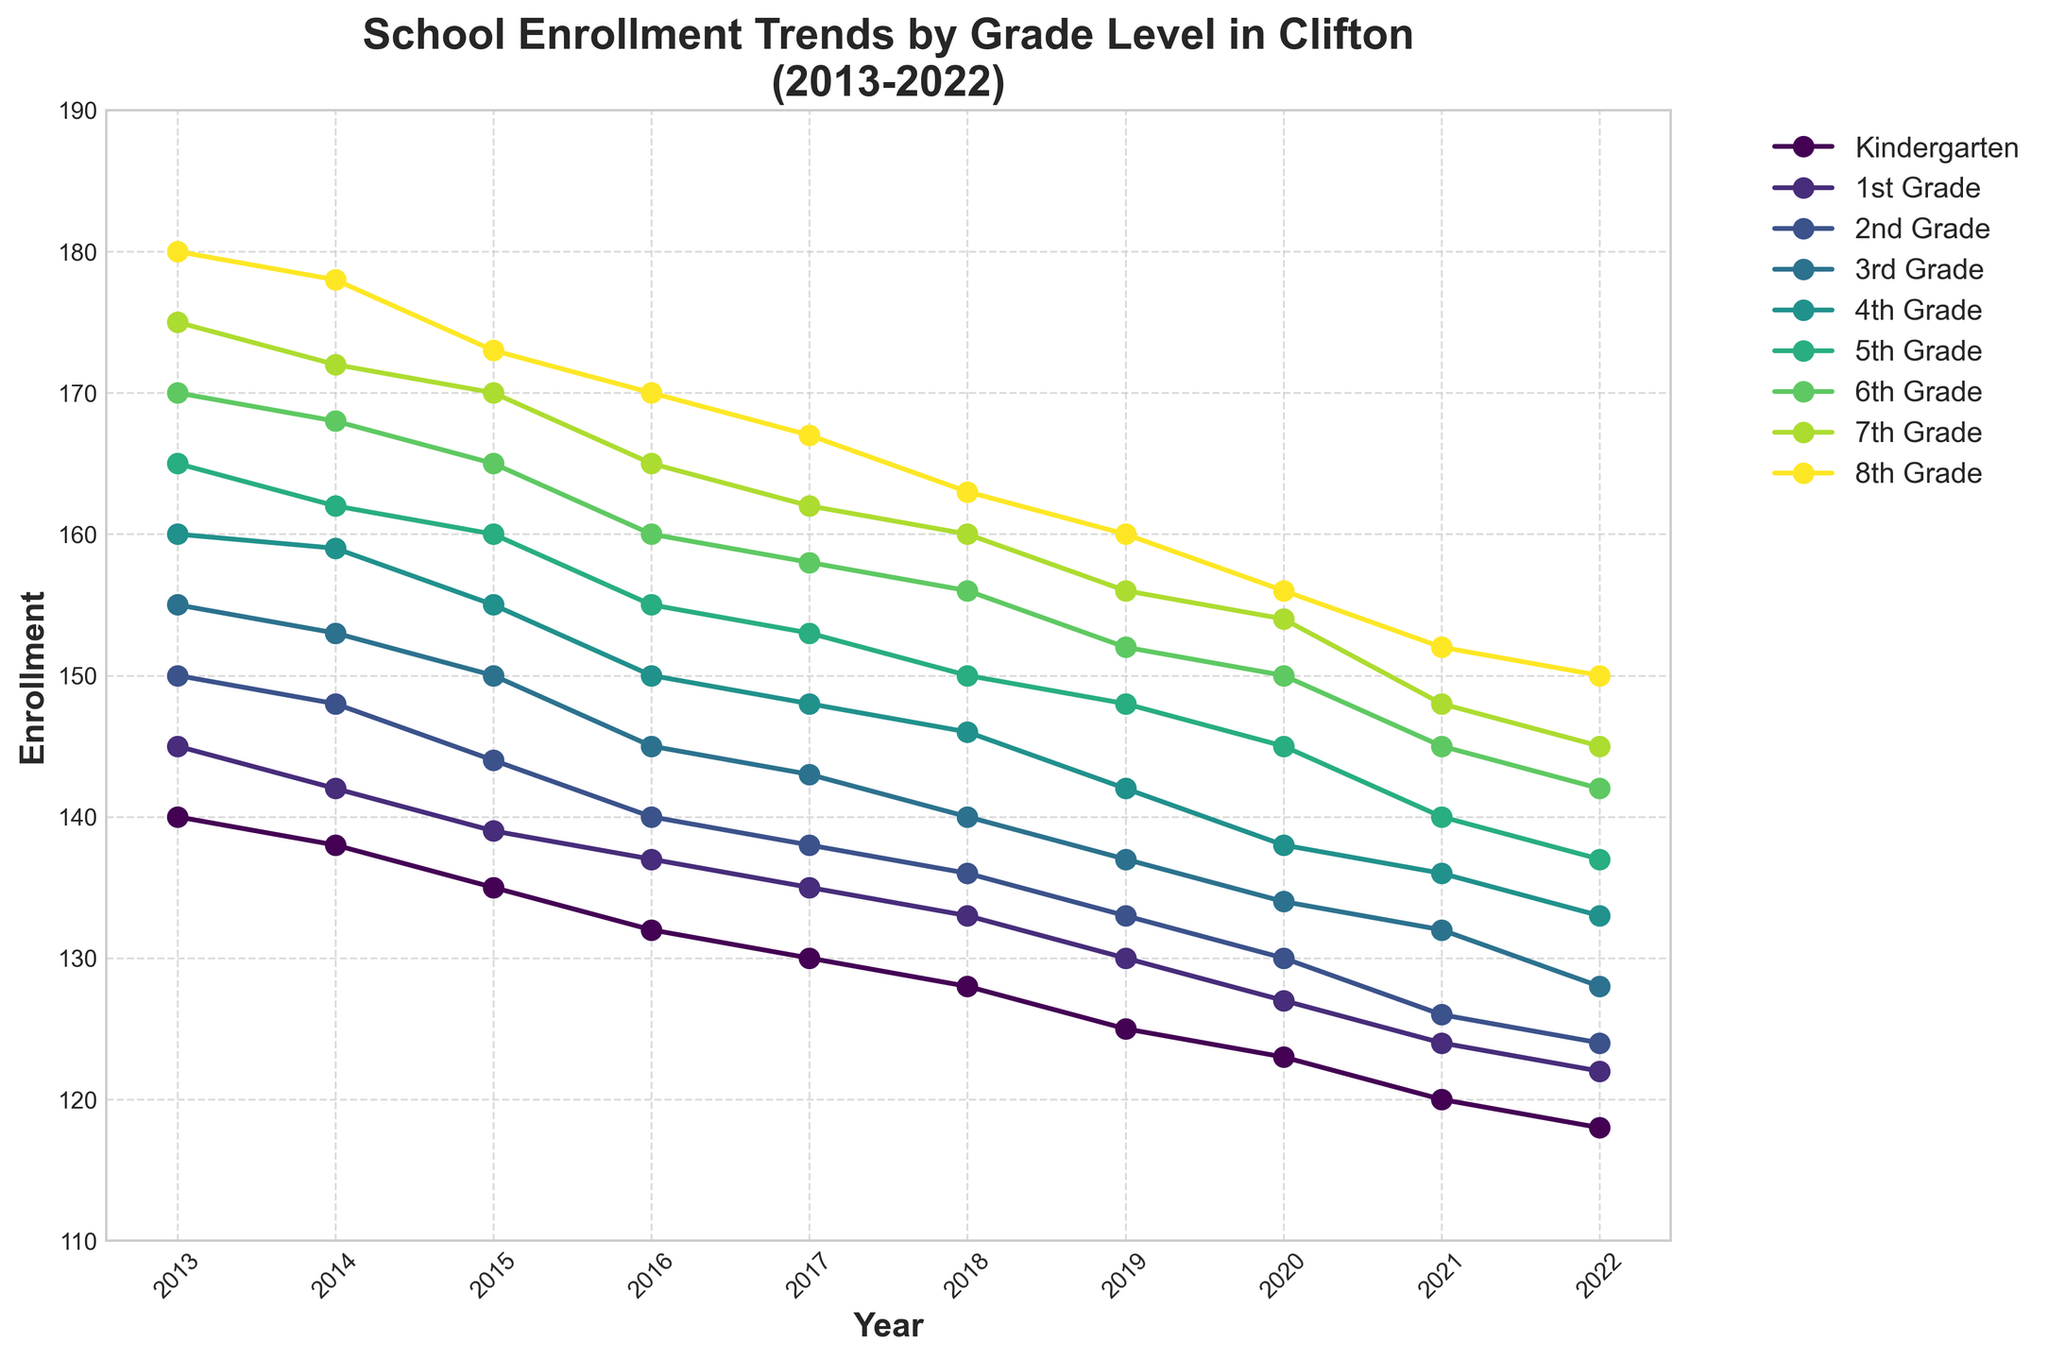What is the range of years shown in the plot? The x-axis displays the years that are covered in this time series plot. By looking at the leftmost and rightmost tick labels on the x-axis, we can determine the range of years.
Answer: 2013 to 2022 What trend can be observed for Kindergarten enrollment from 2013 to 2022? By observing the trend line for Kindergarten in the plot, we can see if it is increasing, decreasing, or stable over the years. The number of enrolled students is consistently decreasing year by year.
Answer: Decreasing Which grade had the highest enrollment in 2022? To determine the grade with the highest enrollment in 2022, observe the endpoints of each grade's line in the plot and identify the one that is at the highest position on the y-axis for the year 2022.
Answer: 8th Grade How does the enrollment for 5th Grade in 2020 compare to 2018? Look at the specific data points for 5th Grade in the years 2020 and 2018 and compare the y-axis values to see if the enrollment increased, decreased, or remained the same.
Answer: Decreased What is the average enrollment for 3rd Grade from 2013 to 2022? Identify and sum the enrollment values for 3rd Grade for every year from 2013 to 2022, and then divide by the number of years (10) to find the average. The sum is 155 + 153 + 150 + 145 + 143 + 140 + 137 + 134 + 132 + 128 = 1417. Dividing by 10 yields 141.7.
Answer: 141.7 In which year did 7th Grade see the highest enrollment? Look at the enrollment values for 7th Grade across all years and identify the highest y-axis value to determine the specific year.
Answer: 2013 Which grades show a generally downward trend throughout the given years? To find grades with a downward trend, visually inspect each grade's line from 2013 to 2022 to see if their lines consistently slope downwards. Kindergarten, 1st Grade, 2nd Grade, 3rd Grade, 4th Grade, 5th Grade, 6th Grade, and 7th Grade follow this trend.
Answer: Kindergarten, 1st Grade, 2nd Grade, 3rd Grade, 4th Grade, 5th Grade, 6th Grade, 7th Grade What is the difference in enrollment for 4th Grade between the years 2015 and 2018? Subtract the enrollment value of 4th Grade in 2018 from its value in 2015. Enrollment for 2015 is 155 and for 2018 is 146, so the difference is 155 - 146.
Answer: 9 Which grade had the smallest enrollment in 2017, and what was the value? Identify the grade with the lowest y-axis value for the year 2017 by comparing the positions of all grades' points. The smallest is Kindergarten with 130 students.
Answer: Kindergarten, 130 